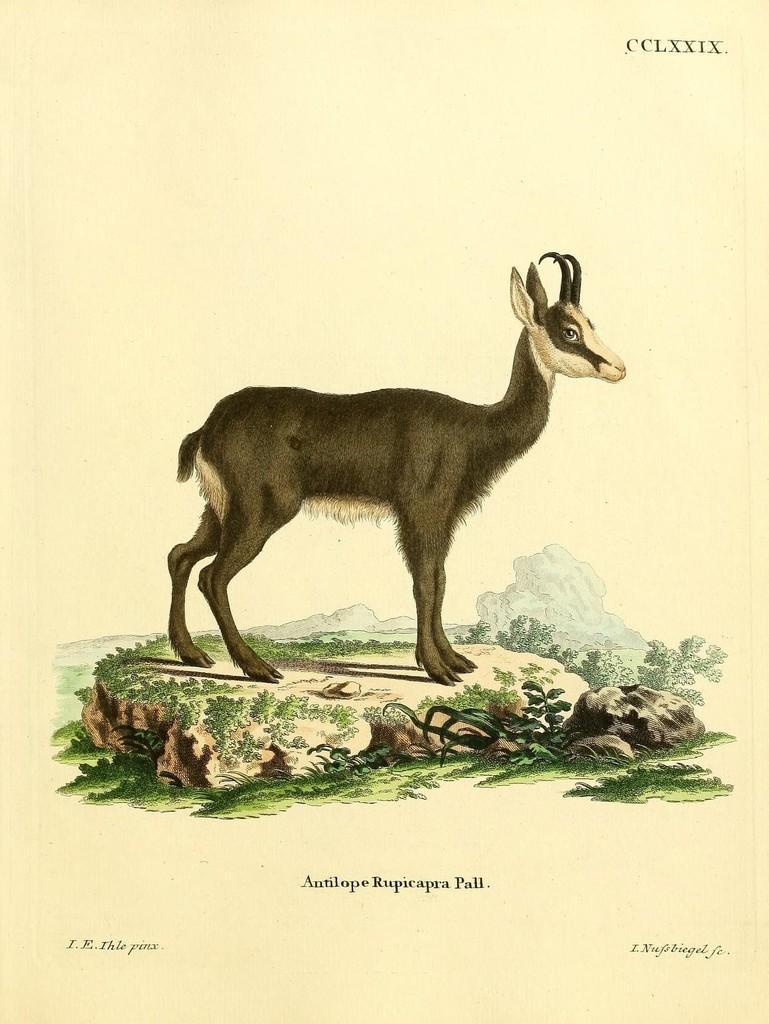Please provide a concise description of this image. In this image we can see drawing of a animal on the ground and some text on it. 